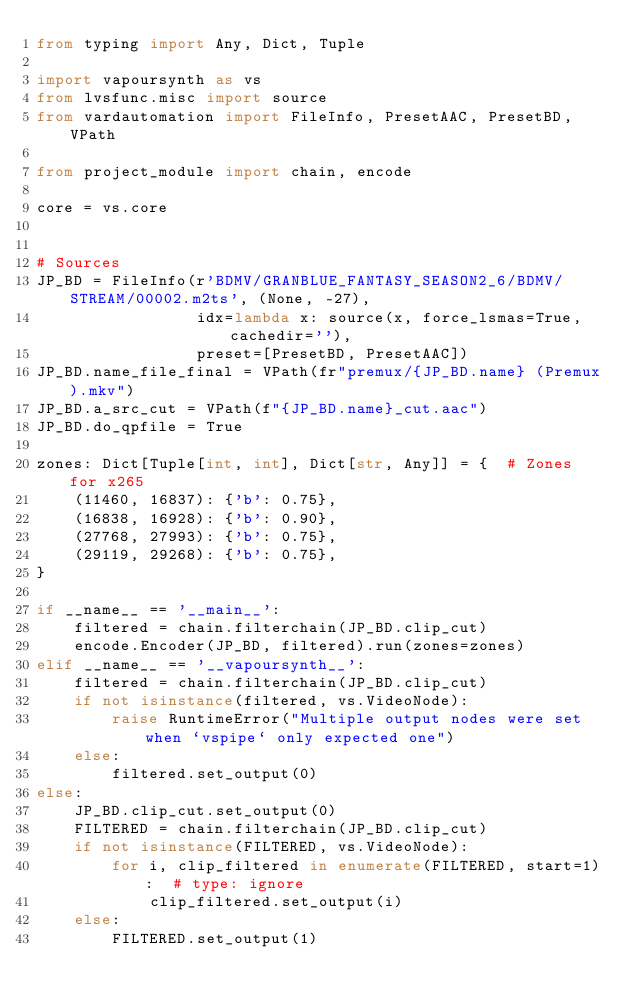Convert code to text. <code><loc_0><loc_0><loc_500><loc_500><_Python_>from typing import Any, Dict, Tuple

import vapoursynth as vs
from lvsfunc.misc import source
from vardautomation import FileInfo, PresetAAC, PresetBD, VPath

from project_module import chain, encode

core = vs.core


# Sources
JP_BD = FileInfo(r'BDMV/GRANBLUE_FANTASY_SEASON2_6/BDMV/STREAM/00002.m2ts', (None, -27),
                 idx=lambda x: source(x, force_lsmas=True, cachedir=''),
                 preset=[PresetBD, PresetAAC])
JP_BD.name_file_final = VPath(fr"premux/{JP_BD.name} (Premux).mkv")
JP_BD.a_src_cut = VPath(f"{JP_BD.name}_cut.aac")
JP_BD.do_qpfile = True

zones: Dict[Tuple[int, int], Dict[str, Any]] = {  # Zones for x265
    (11460, 16837): {'b': 0.75},
    (16838, 16928): {'b': 0.90},
    (27768, 27993): {'b': 0.75},
    (29119, 29268): {'b': 0.75},
}

if __name__ == '__main__':
    filtered = chain.filterchain(JP_BD.clip_cut)
    encode.Encoder(JP_BD, filtered).run(zones=zones)
elif __name__ == '__vapoursynth__':
    filtered = chain.filterchain(JP_BD.clip_cut)
    if not isinstance(filtered, vs.VideoNode):
        raise RuntimeError("Multiple output nodes were set when `vspipe` only expected one")
    else:
        filtered.set_output(0)
else:
    JP_BD.clip_cut.set_output(0)
    FILTERED = chain.filterchain(JP_BD.clip_cut)
    if not isinstance(FILTERED, vs.VideoNode):
        for i, clip_filtered in enumerate(FILTERED, start=1):  # type: ignore
            clip_filtered.set_output(i)
    else:
        FILTERED.set_output(1)
</code> 